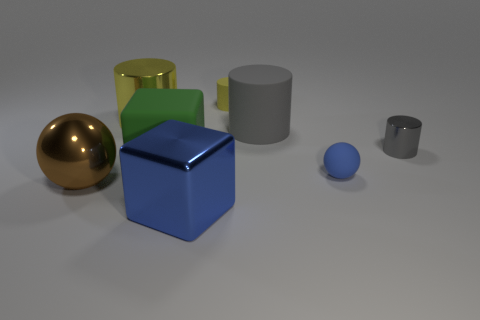Are the small gray thing and the big green cube made of the same material?
Provide a short and direct response. No. Is there a green metal thing of the same size as the blue sphere?
Your answer should be very brief. No. There is another cylinder that is the same size as the gray metal cylinder; what is its material?
Make the answer very short. Rubber. Is there a tiny matte thing of the same shape as the blue metallic thing?
Keep it short and to the point. No. There is a tiny thing that is the same color as the big metallic cube; what is it made of?
Your response must be concise. Rubber. The blue thing that is behind the large blue metal cube has what shape?
Give a very brief answer. Sphere. How many large cyan blocks are there?
Your answer should be very brief. 0. There is a large ball that is made of the same material as the large yellow cylinder; what color is it?
Your response must be concise. Brown. What number of small objects are either matte cylinders or brown things?
Ensure brevity in your answer.  1. There is a gray rubber object; what number of large yellow shiny cylinders are on the right side of it?
Ensure brevity in your answer.  0. 